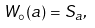<formula> <loc_0><loc_0><loc_500><loc_500>W _ { \circ } ( a ) = S _ { a } ,</formula> 